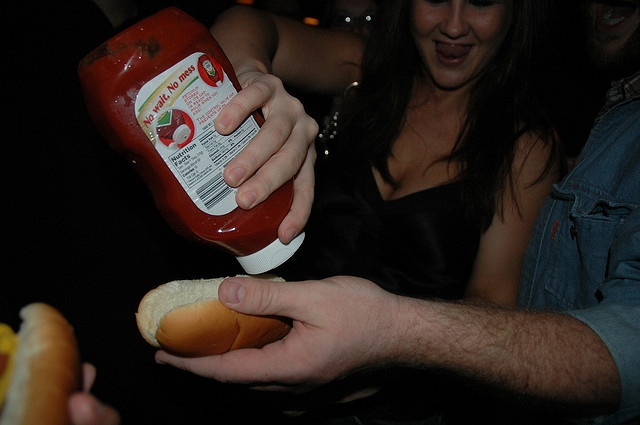Describe the objects in this image and their specific colors. I can see people in black, maroon, and gray tones, people in black, gray, and maroon tones, bottle in black, maroon, darkgray, and gray tones, hot dog in black, olive, maroon, and gray tones, and hot dog in black, maroon, gray, and darkgray tones in this image. 